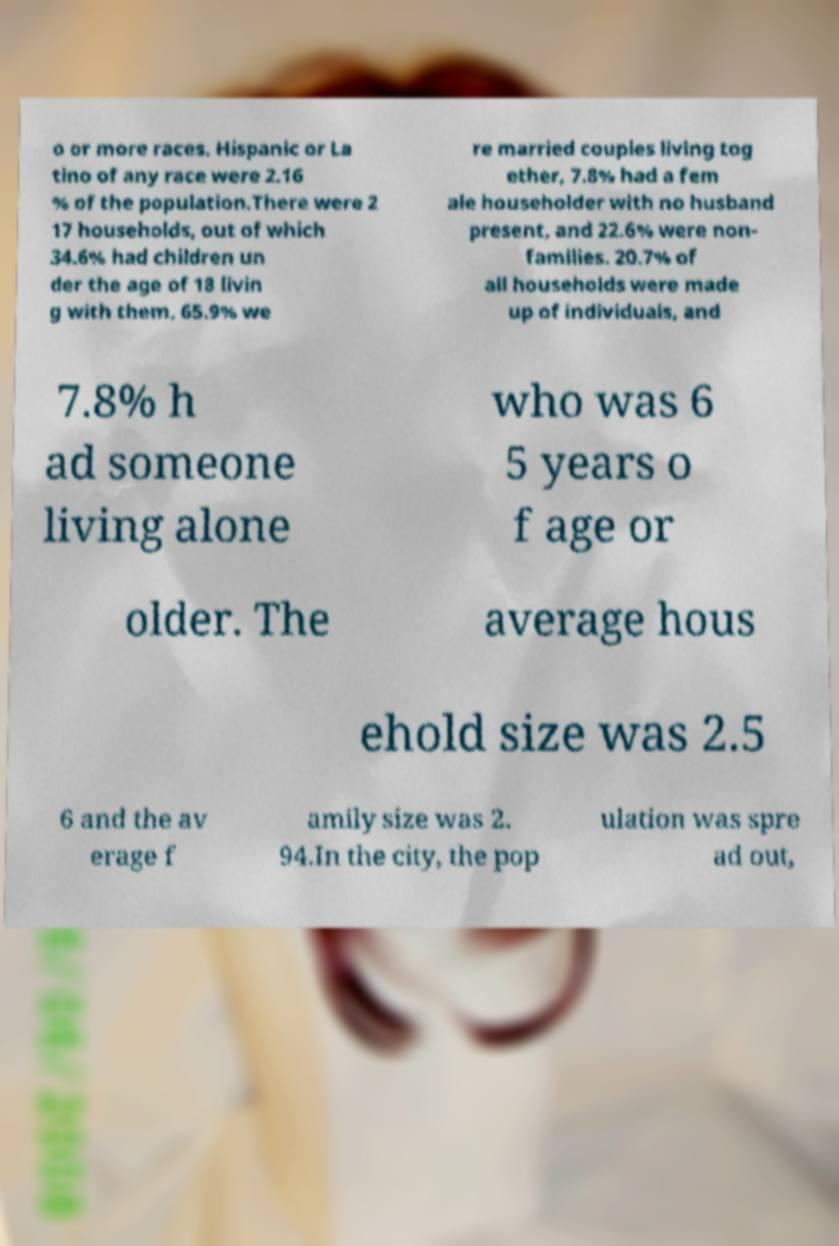Please read and relay the text visible in this image. What does it say? o or more races. Hispanic or La tino of any race were 2.16 % of the population.There were 2 17 households, out of which 34.6% had children un der the age of 18 livin g with them, 65.9% we re married couples living tog ether, 7.8% had a fem ale householder with no husband present, and 22.6% were non- families. 20.7% of all households were made up of individuals, and 7.8% h ad someone living alone who was 6 5 years o f age or older. The average hous ehold size was 2.5 6 and the av erage f amily size was 2. 94.In the city, the pop ulation was spre ad out, 